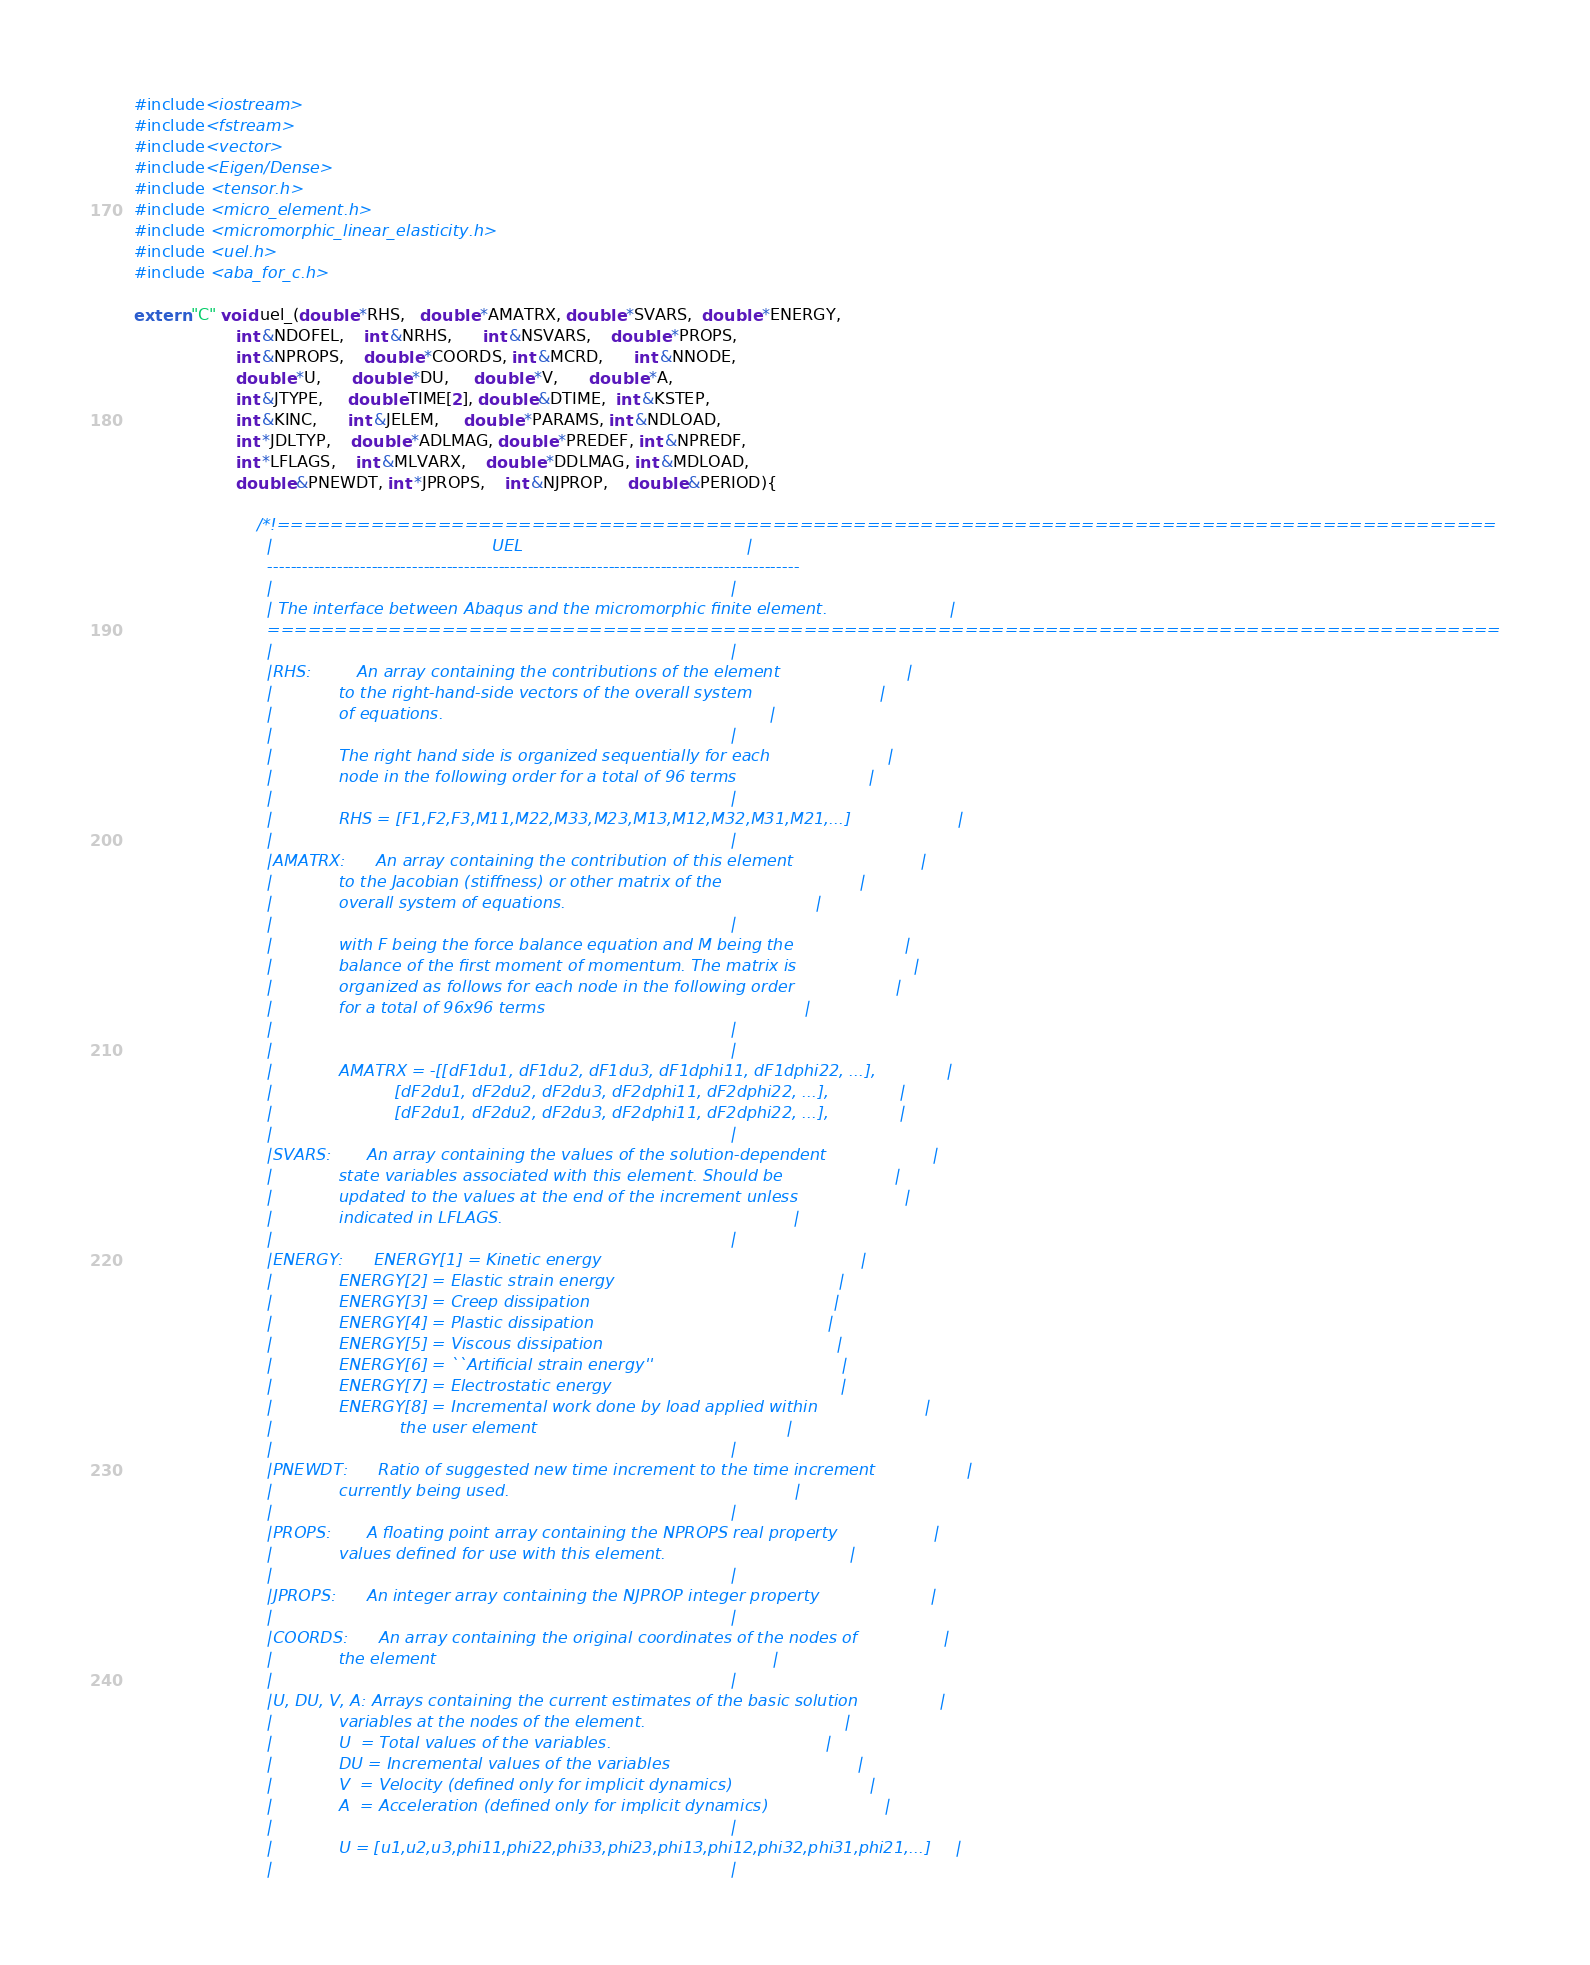Convert code to text. <code><loc_0><loc_0><loc_500><loc_500><_C++_>#include<iostream>
#include<fstream>
#include<vector>
#include<Eigen/Dense>
#include <tensor.h>
#include <micro_element.h>
#include <micromorphic_linear_elasticity.h>
#include <uel.h>
#include <aba_for_c.h>

extern "C" void uel_(double *RHS,   double *AMATRX, double *SVARS,  double *ENERGY,
                    int &NDOFEL,    int &NRHS,      int &NSVARS,    double *PROPS, 
                    int &NPROPS,    double *COORDS, int &MCRD,      int &NNODE,
                    double *U,      double *DU,     double *V,      double *A,
                    int &JTYPE,     double TIME[2], double &DTIME,  int &KSTEP,
                    int &KINC,      int &JELEM,     double *PARAMS, int &NDLOAD,
                    int *JDLTYP,    double *ADLMAG, double *PREDEF, int &NPREDF,
                    int *LFLAGS,    int &MLVARX,    double *DDLMAG, int &MDLOAD,
                    double &PNEWDT, int *JPROPS,    int &NJPROP,    double &PERIOD){
                        
                        /*!===========================================================================================
                          |                                           UEL                                            |
                          --------------------------------------------------------------------------------------------
                          |                                                                                          |
                          | The interface between Abaqus and the micromorphic finite element.                        |
                          ============================================================================================
                          |                                                                                          |
                          |RHS:         An array containing the contributions of the element                         |
                          |             to the right-hand-side vectors of the overall system                         |
                          |             of equations.                                                                |
                          |                                                                                          |
                          |             The right hand side is organized sequentially for each                       |
                          |             node in the following order for a total of 96 terms                          |
                          |                                                                                          |
                          |             RHS = [F1,F2,F3,M11,M22,M33,M23,M13,M12,M32,M31,M21,...]                     |
                          |                                                                                          |
                          |AMATRX:      An array containing the contribution of this element                         |
                          |             to the Jacobian (stiffness) or other matrix of the                           |
                          |             overall system of equations.                                                 |
                          |                                                                                          |
                          |             with F being the force balance equation and M being the                      |
                          |             balance of the first moment of momentum. The matrix is                       |
                          |             organized as follows for each node in the following order                    |
                          |             for a total of 96x96 terms                                                   |
                          |                                                                                          |
                          |                                                                                          |
                          |             AMATRX = -[[dF1du1, dF1du2, dF1du3, dF1dphi11, dF1dphi22, ...],              |
                          |                        [dF2du1, dF2du2, dF2du3, dF2dphi11, dF2dphi22, ...],              |
                          |                        [dF2du1, dF2du2, dF2du3, dF2dphi11, dF2dphi22, ...],              |
                          |                                                                                          |
                          |SVARS:       An array containing the values of the solution-dependent                     |
                          |             state variables associated with this element. Should be                      |
                          |             updated to the values at the end of the increment unless                     |
                          |             indicated in LFLAGS.                                                         |
                          |                                                                                          |
                          |ENERGY:      ENERGY[1] = Kinetic energy                                                   |
                          |             ENERGY[2] = Elastic strain energy                                            |
                          |             ENERGY[3] = Creep dissipation                                                |
                          |             ENERGY[4] = Plastic dissipation                                              |
                          |             ENERGY[5] = Viscous dissipation                                              |
                          |             ENERGY[6] = ``Artificial strain energy''                                     |
                          |             ENERGY[7] = Electrostatic energy                                             |
                          |             ENERGY[8] = Incremental work done by load applied within                     |
                          |                         the user element                                                 |
                          |                                                                                          |
                          |PNEWDT:      Ratio of suggested new time increment to the time increment                  |
                          |             currently being used.                                                        |
                          |                                                                                          |
                          |PROPS:       A floating point array containing the NPROPS real property                   |
                          |             values defined for use with this element.                                    |
                          |                                                                                          |
                          |JPROPS:      An integer array containing the NJPROP integer property                      |
                          |                                                                                          |
                          |COORDS:      An array containing the original coordinates of the nodes of                 |
                          |             the element                                                                  |
                          |                                                                                          |
                          |U, DU, V, A: Arrays containing the current estimates of the basic solution                |
                          |             variables at the nodes of the element.                                       |
                          |             U  = Total values of the variables.                                          |
                          |             DU = Incremental values of the variables                                     |
                          |             V  = Velocity (defined only for implicit dynamics)                           |
                          |             A  = Acceleration (defined only for implicit dynamics)                       |
                          |                                                                                          |
                          |             U = [u1,u2,u3,phi11,phi22,phi33,phi23,phi13,phi12,phi32,phi31,phi21,...]     |
                          |                                                                                          |</code> 